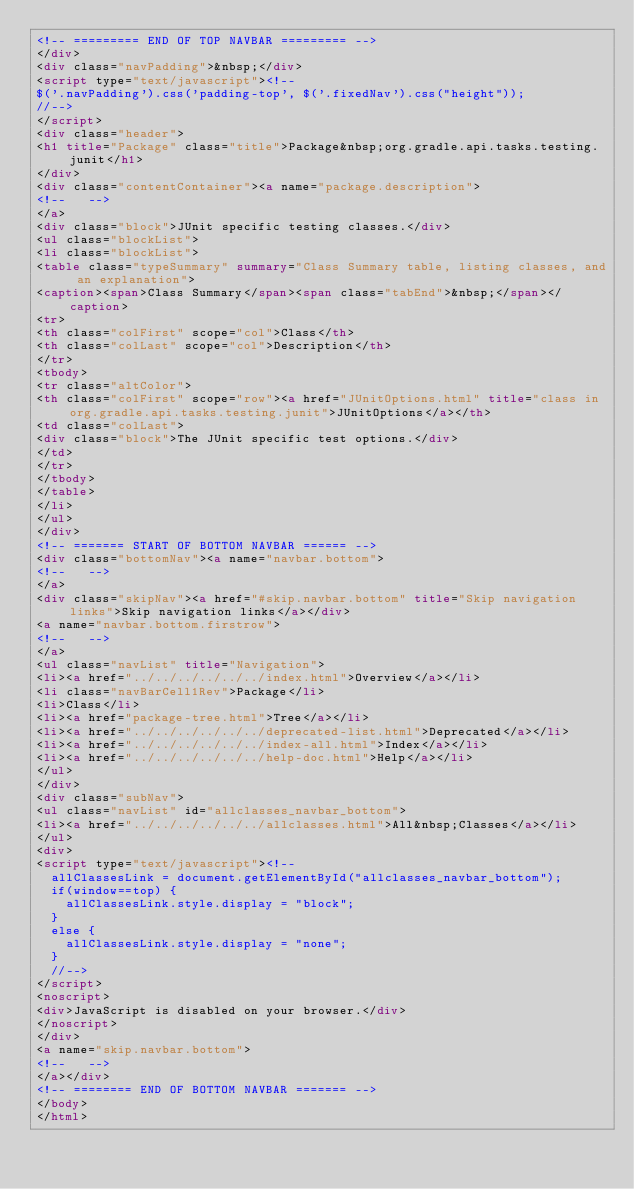<code> <loc_0><loc_0><loc_500><loc_500><_HTML_><!-- ========= END OF TOP NAVBAR ========= -->
</div>
<div class="navPadding">&nbsp;</div>
<script type="text/javascript"><!--
$('.navPadding').css('padding-top', $('.fixedNav').css("height"));
//-->
</script>
<div class="header">
<h1 title="Package" class="title">Package&nbsp;org.gradle.api.tasks.testing.junit</h1>
</div>
<div class="contentContainer"><a name="package.description">
<!--   -->
</a>
<div class="block">JUnit specific testing classes.</div>
<ul class="blockList">
<li class="blockList">
<table class="typeSummary" summary="Class Summary table, listing classes, and an explanation">
<caption><span>Class Summary</span><span class="tabEnd">&nbsp;</span></caption>
<tr>
<th class="colFirst" scope="col">Class</th>
<th class="colLast" scope="col">Description</th>
</tr>
<tbody>
<tr class="altColor">
<th class="colFirst" scope="row"><a href="JUnitOptions.html" title="class in org.gradle.api.tasks.testing.junit">JUnitOptions</a></th>
<td class="colLast">
<div class="block">The JUnit specific test options.</div>
</td>
</tr>
</tbody>
</table>
</li>
</ul>
</div>
<!-- ======= START OF BOTTOM NAVBAR ====== -->
<div class="bottomNav"><a name="navbar.bottom">
<!--   -->
</a>
<div class="skipNav"><a href="#skip.navbar.bottom" title="Skip navigation links">Skip navigation links</a></div>
<a name="navbar.bottom.firstrow">
<!--   -->
</a>
<ul class="navList" title="Navigation">
<li><a href="../../../../../../index.html">Overview</a></li>
<li class="navBarCell1Rev">Package</li>
<li>Class</li>
<li><a href="package-tree.html">Tree</a></li>
<li><a href="../../../../../../deprecated-list.html">Deprecated</a></li>
<li><a href="../../../../../../index-all.html">Index</a></li>
<li><a href="../../../../../../help-doc.html">Help</a></li>
</ul>
</div>
<div class="subNav">
<ul class="navList" id="allclasses_navbar_bottom">
<li><a href="../../../../../../allclasses.html">All&nbsp;Classes</a></li>
</ul>
<div>
<script type="text/javascript"><!--
  allClassesLink = document.getElementById("allclasses_navbar_bottom");
  if(window==top) {
    allClassesLink.style.display = "block";
  }
  else {
    allClassesLink.style.display = "none";
  }
  //-->
</script>
<noscript>
<div>JavaScript is disabled on your browser.</div>
</noscript>
</div>
<a name="skip.navbar.bottom">
<!--   -->
</a></div>
<!-- ======== END OF BOTTOM NAVBAR ======= -->
</body>
</html>
</code> 